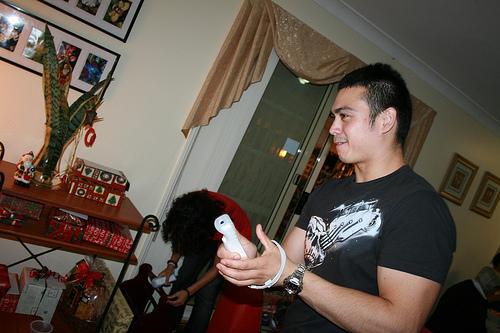What time of year is it?
Keep it brief. Christmas. What room is he in?
Concise answer only. Living room. Does he have a skull on his shirt?
Write a very short answer. Yes. 